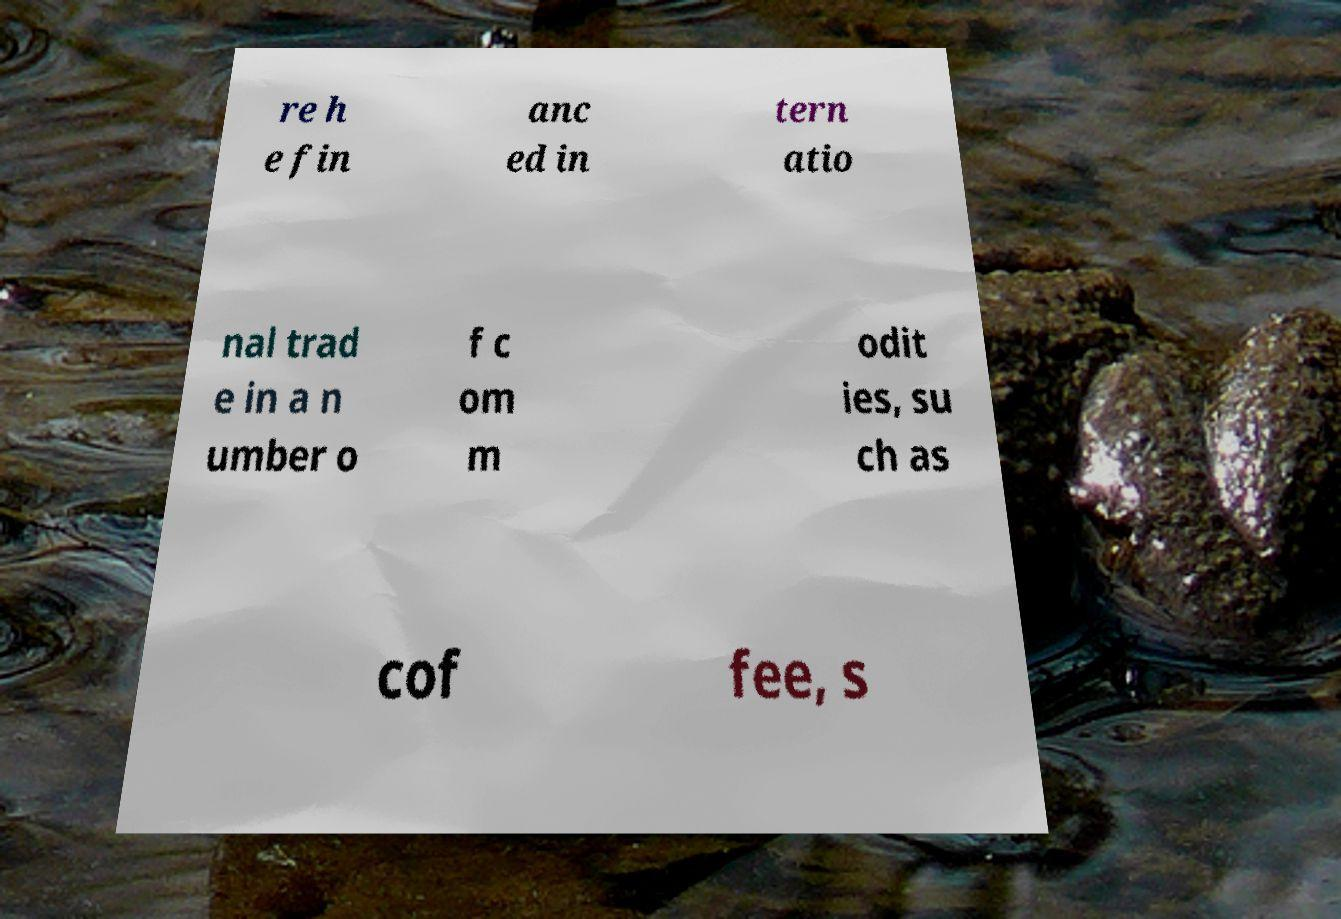There's text embedded in this image that I need extracted. Can you transcribe it verbatim? re h e fin anc ed in tern atio nal trad e in a n umber o f c om m odit ies, su ch as cof fee, s 